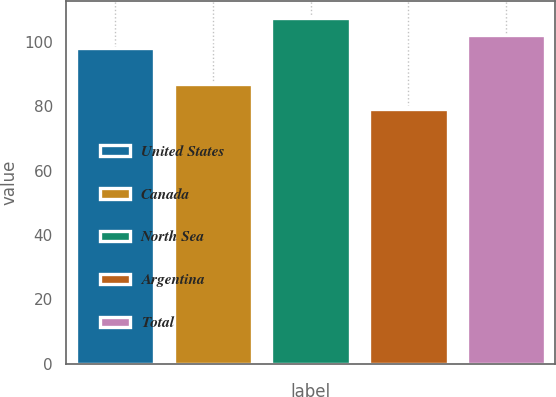<chart> <loc_0><loc_0><loc_500><loc_500><bar_chart><fcel>United States<fcel>Canada<fcel>North Sea<fcel>Argentina<fcel>Total<nl><fcel>98.14<fcel>87<fcel>107.48<fcel>79.05<fcel>101.99<nl></chart> 